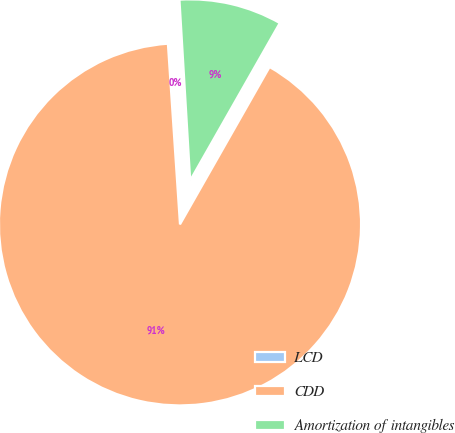Convert chart. <chart><loc_0><loc_0><loc_500><loc_500><pie_chart><fcel>LCD<fcel>CDD<fcel>Amortization of intangibles<nl><fcel>0.12%<fcel>90.7%<fcel>9.18%<nl></chart> 